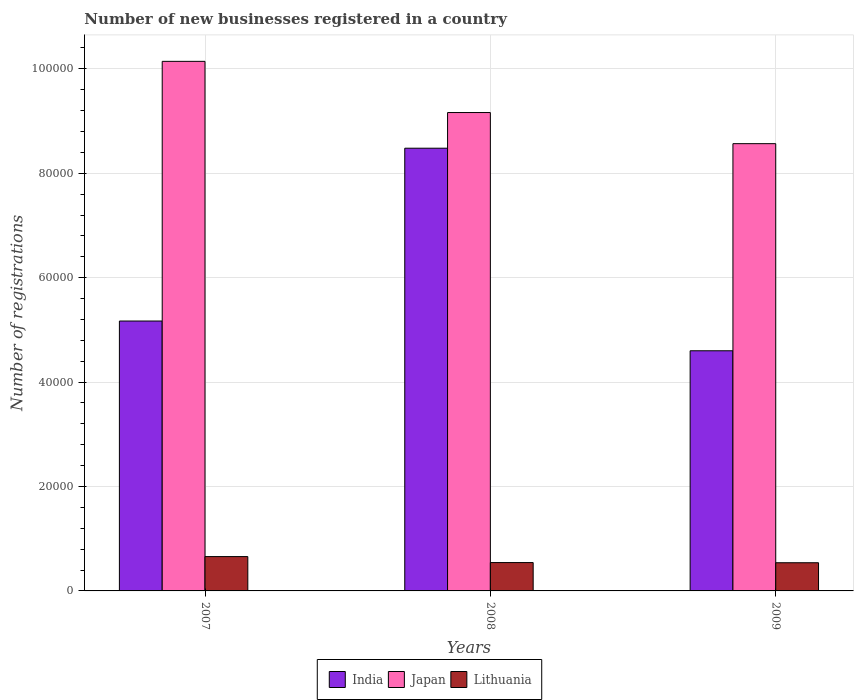How many different coloured bars are there?
Ensure brevity in your answer.  3. How many groups of bars are there?
Your response must be concise. 3. Are the number of bars on each tick of the X-axis equal?
Your answer should be compact. Yes. In how many cases, is the number of bars for a given year not equal to the number of legend labels?
Offer a terse response. 0. What is the number of new businesses registered in Lithuania in 2009?
Provide a short and direct response. 5399. Across all years, what is the maximum number of new businesses registered in India?
Make the answer very short. 8.48e+04. Across all years, what is the minimum number of new businesses registered in India?
Your answer should be very brief. 4.60e+04. What is the total number of new businesses registered in India in the graph?
Keep it short and to the point. 1.82e+05. What is the difference between the number of new businesses registered in Japan in 2008 and that in 2009?
Give a very brief answer. 5962. What is the difference between the number of new businesses registered in Japan in 2007 and the number of new businesses registered in India in 2009?
Your response must be concise. 5.54e+04. What is the average number of new businesses registered in Japan per year?
Give a very brief answer. 9.29e+04. In the year 2009, what is the difference between the number of new businesses registered in Lithuania and number of new businesses registered in India?
Offer a very short reply. -4.06e+04. What is the ratio of the number of new businesses registered in Japan in 2007 to that in 2009?
Make the answer very short. 1.18. Is the difference between the number of new businesses registered in Lithuania in 2008 and 2009 greater than the difference between the number of new businesses registered in India in 2008 and 2009?
Offer a terse response. No. What is the difference between the highest and the second highest number of new businesses registered in Lithuania?
Your response must be concise. 1146. What is the difference between the highest and the lowest number of new businesses registered in Lithuania?
Provide a succinct answer. 1179. In how many years, is the number of new businesses registered in Lithuania greater than the average number of new businesses registered in Lithuania taken over all years?
Provide a short and direct response. 1. What does the 1st bar from the left in 2008 represents?
Make the answer very short. India. How many bars are there?
Provide a succinct answer. 9. Are all the bars in the graph horizontal?
Keep it short and to the point. No. Are the values on the major ticks of Y-axis written in scientific E-notation?
Keep it short and to the point. No. Does the graph contain grids?
Make the answer very short. Yes. Where does the legend appear in the graph?
Ensure brevity in your answer.  Bottom center. What is the title of the graph?
Give a very brief answer. Number of new businesses registered in a country. What is the label or title of the X-axis?
Keep it short and to the point. Years. What is the label or title of the Y-axis?
Provide a succinct answer. Number of registrations. What is the Number of registrations of India in 2007?
Offer a terse response. 5.17e+04. What is the Number of registrations of Japan in 2007?
Keep it short and to the point. 1.01e+05. What is the Number of registrations of Lithuania in 2007?
Offer a very short reply. 6578. What is the Number of registrations in India in 2008?
Provide a succinct answer. 8.48e+04. What is the Number of registrations in Japan in 2008?
Offer a terse response. 9.16e+04. What is the Number of registrations of Lithuania in 2008?
Give a very brief answer. 5432. What is the Number of registrations of India in 2009?
Provide a succinct answer. 4.60e+04. What is the Number of registrations of Japan in 2009?
Your response must be concise. 8.57e+04. What is the Number of registrations in Lithuania in 2009?
Provide a short and direct response. 5399. Across all years, what is the maximum Number of registrations in India?
Ensure brevity in your answer.  8.48e+04. Across all years, what is the maximum Number of registrations of Japan?
Keep it short and to the point. 1.01e+05. Across all years, what is the maximum Number of registrations in Lithuania?
Your answer should be very brief. 6578. Across all years, what is the minimum Number of registrations of India?
Your answer should be compact. 4.60e+04. Across all years, what is the minimum Number of registrations in Japan?
Keep it short and to the point. 8.57e+04. Across all years, what is the minimum Number of registrations in Lithuania?
Keep it short and to the point. 5399. What is the total Number of registrations of India in the graph?
Make the answer very short. 1.82e+05. What is the total Number of registrations of Japan in the graph?
Your answer should be very brief. 2.79e+05. What is the total Number of registrations of Lithuania in the graph?
Give a very brief answer. 1.74e+04. What is the difference between the Number of registrations in India in 2007 and that in 2008?
Offer a terse response. -3.31e+04. What is the difference between the Number of registrations in Japan in 2007 and that in 2008?
Give a very brief answer. 9804. What is the difference between the Number of registrations of Lithuania in 2007 and that in 2008?
Ensure brevity in your answer.  1146. What is the difference between the Number of registrations in India in 2007 and that in 2009?
Make the answer very short. 5700. What is the difference between the Number of registrations in Japan in 2007 and that in 2009?
Provide a short and direct response. 1.58e+04. What is the difference between the Number of registrations in Lithuania in 2007 and that in 2009?
Offer a very short reply. 1179. What is the difference between the Number of registrations in India in 2008 and that in 2009?
Keep it short and to the point. 3.88e+04. What is the difference between the Number of registrations of Japan in 2008 and that in 2009?
Give a very brief answer. 5962. What is the difference between the Number of registrations of Lithuania in 2008 and that in 2009?
Your answer should be very brief. 33. What is the difference between the Number of registrations in India in 2007 and the Number of registrations in Japan in 2008?
Provide a short and direct response. -3.99e+04. What is the difference between the Number of registrations in India in 2007 and the Number of registrations in Lithuania in 2008?
Provide a succinct answer. 4.63e+04. What is the difference between the Number of registrations of Japan in 2007 and the Number of registrations of Lithuania in 2008?
Your answer should be compact. 9.60e+04. What is the difference between the Number of registrations of India in 2007 and the Number of registrations of Japan in 2009?
Give a very brief answer. -3.40e+04. What is the difference between the Number of registrations in India in 2007 and the Number of registrations in Lithuania in 2009?
Ensure brevity in your answer.  4.63e+04. What is the difference between the Number of registrations in Japan in 2007 and the Number of registrations in Lithuania in 2009?
Offer a very short reply. 9.60e+04. What is the difference between the Number of registrations in India in 2008 and the Number of registrations in Japan in 2009?
Your answer should be compact. -873. What is the difference between the Number of registrations of India in 2008 and the Number of registrations of Lithuania in 2009?
Ensure brevity in your answer.  7.94e+04. What is the difference between the Number of registrations in Japan in 2008 and the Number of registrations in Lithuania in 2009?
Your response must be concise. 8.62e+04. What is the average Number of registrations of India per year?
Keep it short and to the point. 6.08e+04. What is the average Number of registrations of Japan per year?
Your answer should be compact. 9.29e+04. What is the average Number of registrations in Lithuania per year?
Offer a very short reply. 5803. In the year 2007, what is the difference between the Number of registrations in India and Number of registrations in Japan?
Your answer should be compact. -4.97e+04. In the year 2007, what is the difference between the Number of registrations in India and Number of registrations in Lithuania?
Provide a short and direct response. 4.51e+04. In the year 2007, what is the difference between the Number of registrations of Japan and Number of registrations of Lithuania?
Ensure brevity in your answer.  9.49e+04. In the year 2008, what is the difference between the Number of registrations in India and Number of registrations in Japan?
Ensure brevity in your answer.  -6835. In the year 2008, what is the difference between the Number of registrations of India and Number of registrations of Lithuania?
Your answer should be very brief. 7.94e+04. In the year 2008, what is the difference between the Number of registrations of Japan and Number of registrations of Lithuania?
Ensure brevity in your answer.  8.62e+04. In the year 2009, what is the difference between the Number of registrations of India and Number of registrations of Japan?
Keep it short and to the point. -3.97e+04. In the year 2009, what is the difference between the Number of registrations of India and Number of registrations of Lithuania?
Keep it short and to the point. 4.06e+04. In the year 2009, what is the difference between the Number of registrations of Japan and Number of registrations of Lithuania?
Provide a succinct answer. 8.03e+04. What is the ratio of the Number of registrations in India in 2007 to that in 2008?
Provide a succinct answer. 0.61. What is the ratio of the Number of registrations in Japan in 2007 to that in 2008?
Your answer should be compact. 1.11. What is the ratio of the Number of registrations in Lithuania in 2007 to that in 2008?
Your answer should be compact. 1.21. What is the ratio of the Number of registrations in India in 2007 to that in 2009?
Your response must be concise. 1.12. What is the ratio of the Number of registrations of Japan in 2007 to that in 2009?
Ensure brevity in your answer.  1.18. What is the ratio of the Number of registrations of Lithuania in 2007 to that in 2009?
Keep it short and to the point. 1.22. What is the ratio of the Number of registrations of India in 2008 to that in 2009?
Your response must be concise. 1.84. What is the ratio of the Number of registrations in Japan in 2008 to that in 2009?
Provide a succinct answer. 1.07. What is the ratio of the Number of registrations in Lithuania in 2008 to that in 2009?
Provide a succinct answer. 1.01. What is the difference between the highest and the second highest Number of registrations in India?
Your answer should be very brief. 3.31e+04. What is the difference between the highest and the second highest Number of registrations in Japan?
Provide a short and direct response. 9804. What is the difference between the highest and the second highest Number of registrations of Lithuania?
Your answer should be compact. 1146. What is the difference between the highest and the lowest Number of registrations in India?
Ensure brevity in your answer.  3.88e+04. What is the difference between the highest and the lowest Number of registrations in Japan?
Ensure brevity in your answer.  1.58e+04. What is the difference between the highest and the lowest Number of registrations of Lithuania?
Your answer should be compact. 1179. 